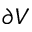Convert formula to latex. <formula><loc_0><loc_0><loc_500><loc_500>\partial V</formula> 